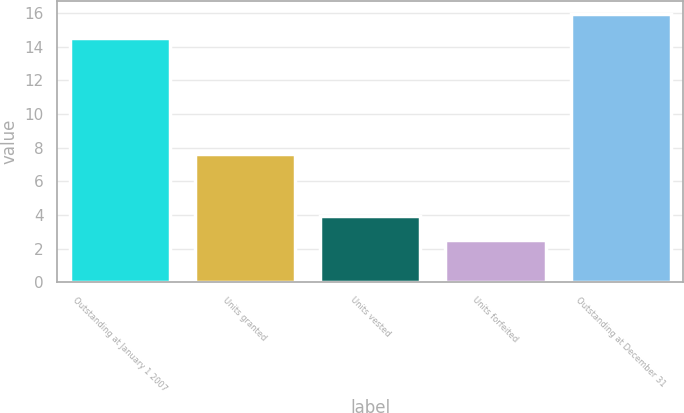Convert chart to OTSL. <chart><loc_0><loc_0><loc_500><loc_500><bar_chart><fcel>Outstanding at January 1 2007<fcel>Units granted<fcel>Units vested<fcel>Units forfeited<fcel>Outstanding at December 31<nl><fcel>14.5<fcel>7.6<fcel>3.92<fcel>2.5<fcel>15.92<nl></chart> 